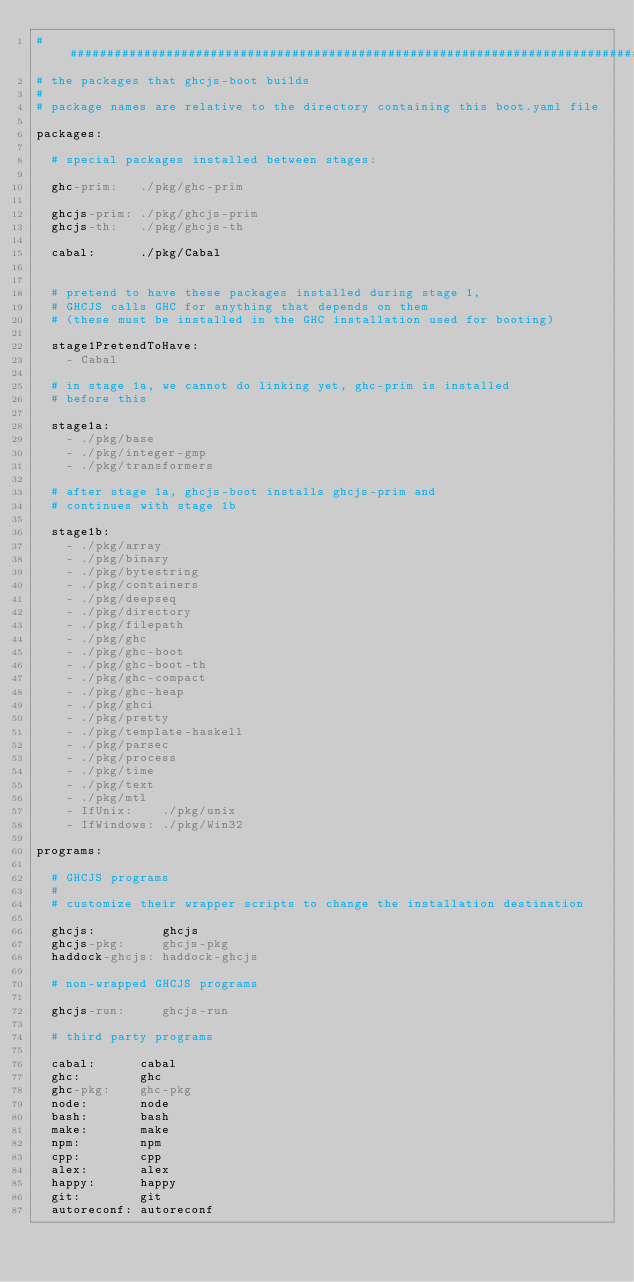Convert code to text. <code><loc_0><loc_0><loc_500><loc_500><_YAML_>###############################################################################
# the packages that ghcjs-boot builds
#
# package names are relative to the directory containing this boot.yaml file

packages:

  # special packages installed between stages:

  ghc-prim:   ./pkg/ghc-prim

  ghcjs-prim: ./pkg/ghcjs-prim
  ghcjs-th:   ./pkg/ghcjs-th

  cabal:      ./pkg/Cabal


  # pretend to have these packages installed during stage 1,
  # GHCJS calls GHC for anything that depends on them
  # (these must be installed in the GHC installation used for booting)

  stage1PretendToHave:
    - Cabal

  # in stage 1a, we cannot do linking yet, ghc-prim is installed
  # before this

  stage1a:
    - ./pkg/base
    - ./pkg/integer-gmp
    - ./pkg/transformers

  # after stage 1a, ghcjs-boot installs ghcjs-prim and
  # continues with stage 1b

  stage1b:
    - ./pkg/array
    - ./pkg/binary
    - ./pkg/bytestring
    - ./pkg/containers
    - ./pkg/deepseq
    - ./pkg/directory
    - ./pkg/filepath
    - ./pkg/ghc
    - ./pkg/ghc-boot
    - ./pkg/ghc-boot-th
    - ./pkg/ghc-compact
    - ./pkg/ghc-heap
    - ./pkg/ghci
    - ./pkg/pretty
    - ./pkg/template-haskell
    - ./pkg/parsec
    - ./pkg/process
    - ./pkg/time
    - ./pkg/text
    - ./pkg/mtl
    - IfUnix:    ./pkg/unix
    - IfWindows: ./pkg/Win32

programs:

  # GHCJS programs
  #
  # customize their wrapper scripts to change the installation destination

  ghcjs:         ghcjs
  ghcjs-pkg:     ghcjs-pkg
  haddock-ghcjs: haddock-ghcjs

  # non-wrapped GHCJS programs

  ghcjs-run:     ghcjs-run

  # third party programs

  cabal:      cabal
  ghc:        ghc
  ghc-pkg:    ghc-pkg
  node:       node
  bash:       bash
  make:       make
  npm:        npm
  cpp:        cpp
  alex:       alex
  happy:      happy
  git:        git
  autoreconf: autoreconf
</code> 